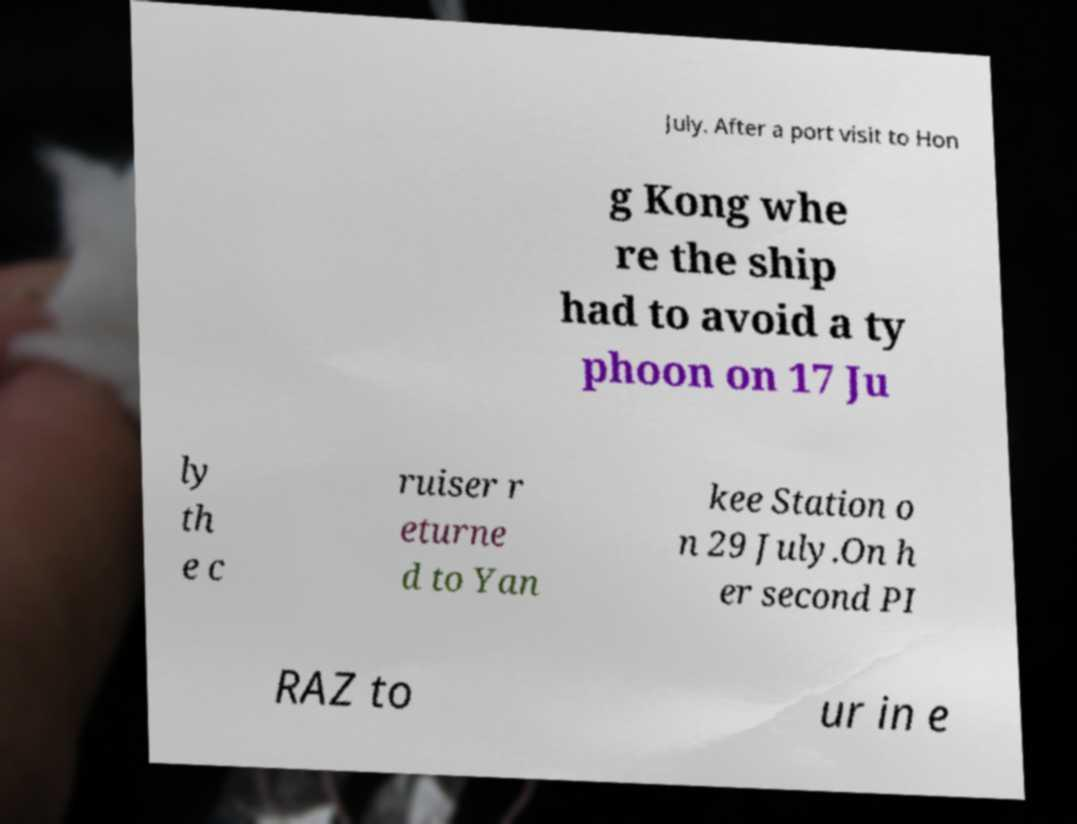Could you assist in decoding the text presented in this image and type it out clearly? July. After a port visit to Hon g Kong whe re the ship had to avoid a ty phoon on 17 Ju ly th e c ruiser r eturne d to Yan kee Station o n 29 July.On h er second PI RAZ to ur in e 